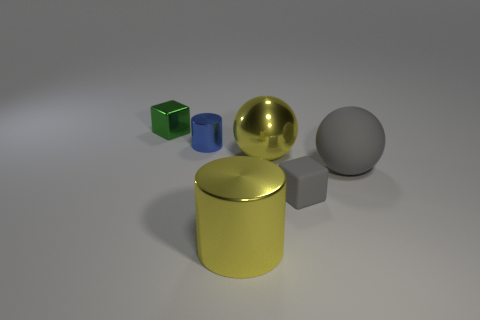Add 3 large metallic cylinders. How many objects exist? 9 Subtract all tiny metallic objects. Subtract all big brown shiny cubes. How many objects are left? 4 Add 4 large yellow metal spheres. How many large yellow metal spheres are left? 5 Add 4 big balls. How many big balls exist? 6 Subtract 0 gray cylinders. How many objects are left? 6 